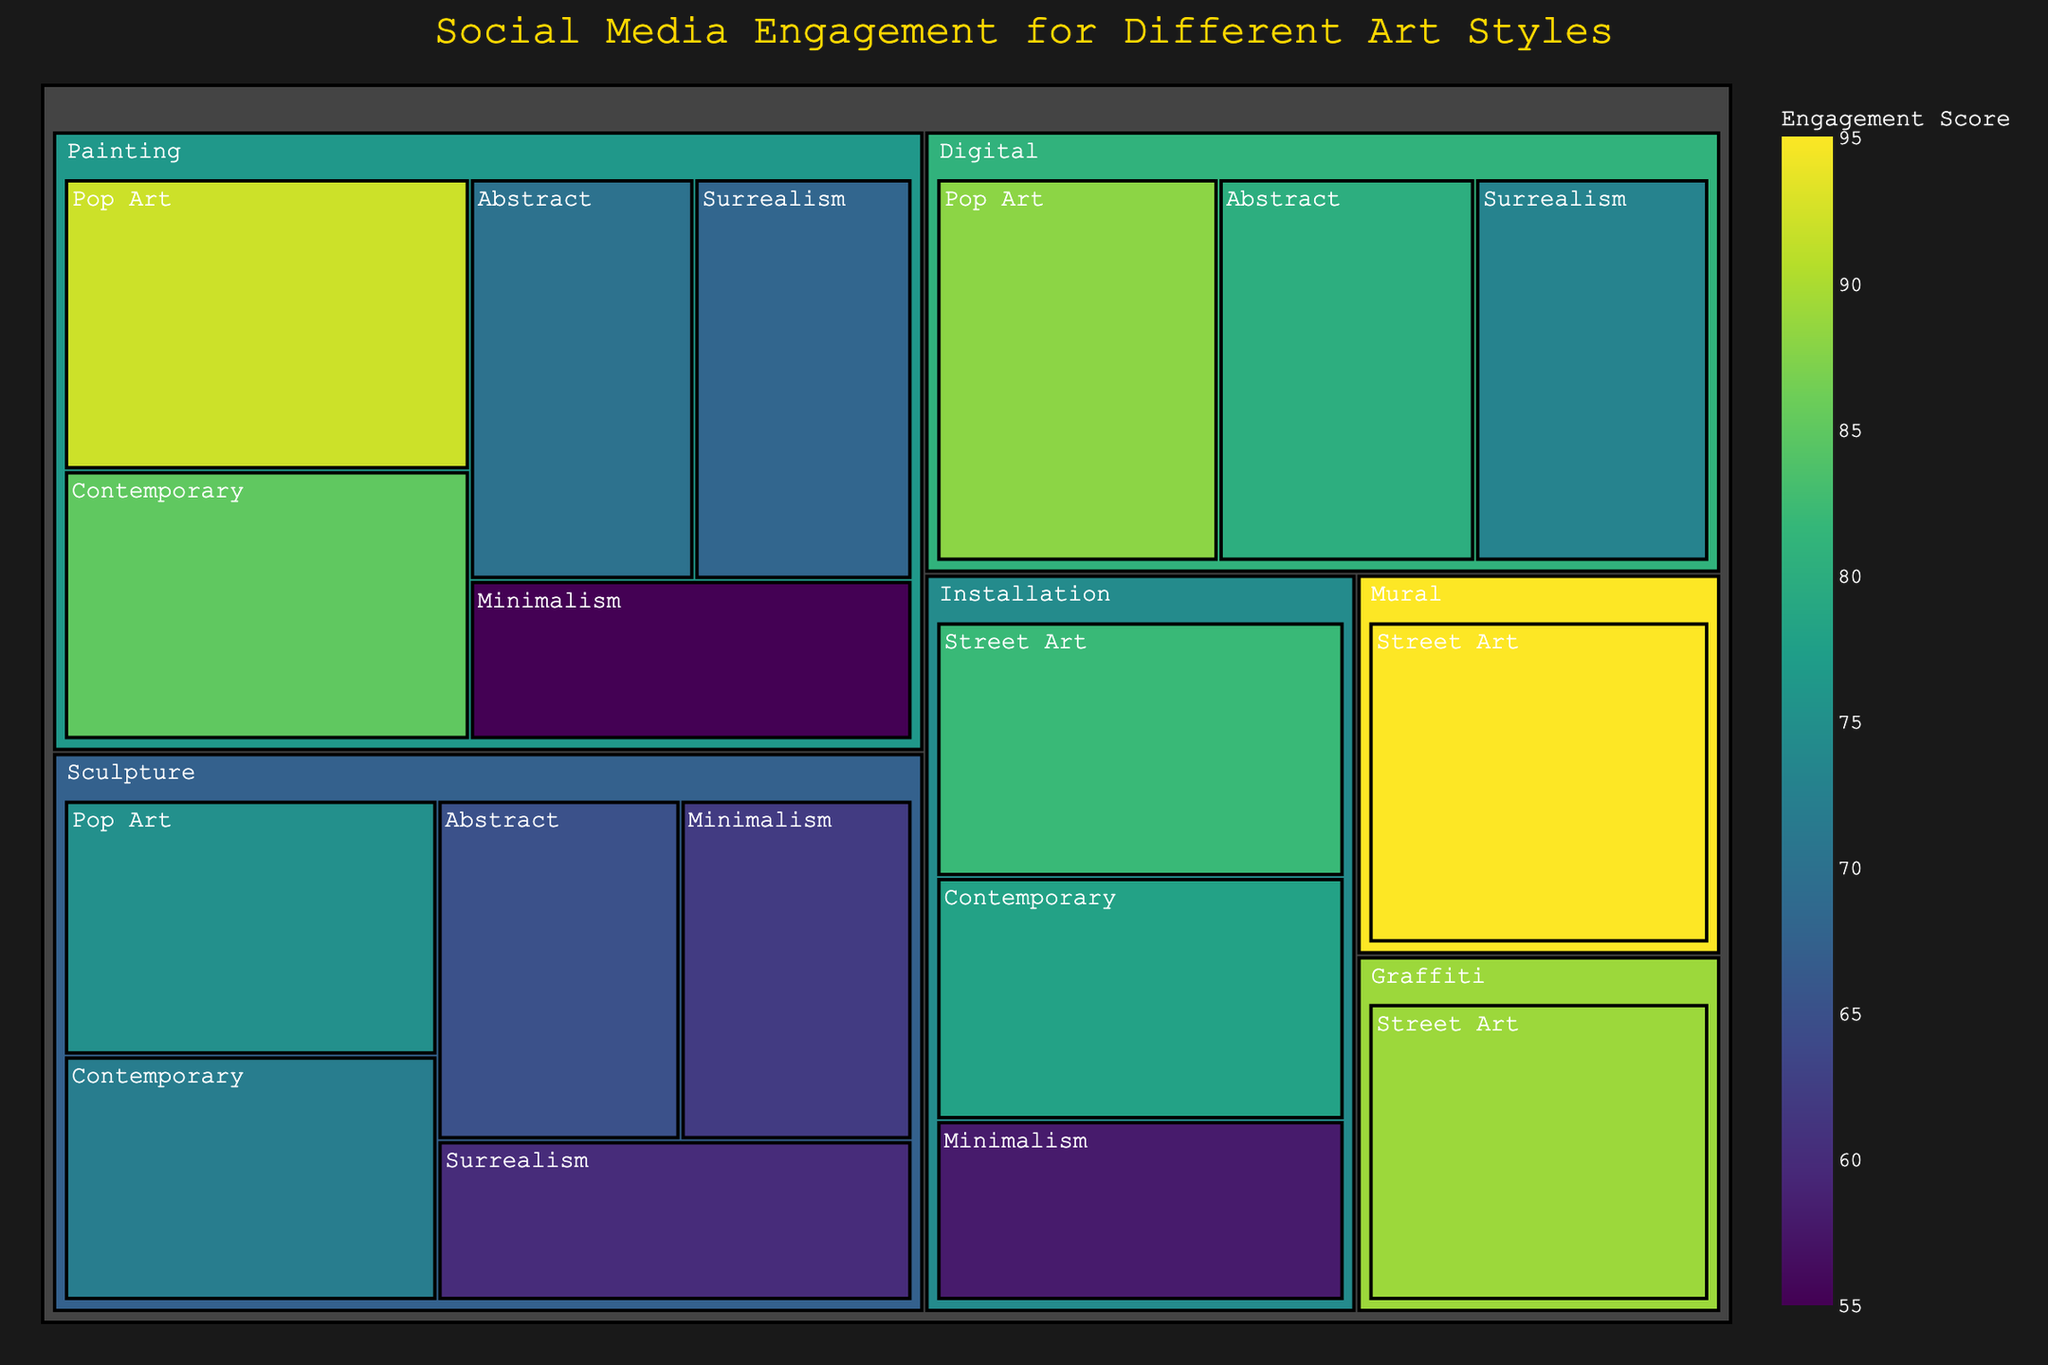What's the title of the treemap? The title of the treemap is displayed at the top center of the figure in a gold color font.
Answer: Social Media Engagement for Different Art Styles Which art style and category combination has the highest engagement score? By looking at the treemap, the largest and darkest green segment represents the highest engagement score.
Answer: Street Art - Mural What's the engagement score for Pop Art in the painting category? Locate the segment labeled 'Pop Art' under 'Painting' in the treemap. The hover data or direct label shows the engagement score.
Answer: 92 How many different categories are shown in the treemap? The treemap is divided into top-level categories shown as the first level of the hierarchy. Count these divisions.
Answer: 6 What is the total engagement score for all Contemporary art styles? Identify and sum all the engagement scores under Contemporary (Painting, Sculpture, Installation). 85 + 72 + 78.
Answer: 235 Which category across all art styles has the lowest engagement score? Locate the smallest and lightest-colored segment within the entire treemap, which indicates the lowest score.
Answer: Minimalism - Painting Compare the engagement scores of Street Art-Graffiti and Pop Art-Digital. Which has a higher score? Find 'Street Art - Graffiti' and 'Pop Art - Digital' in the treemap and compare their engagement scores.
Answer: Pop Art - Digital What is the combined engagement score of all Digital artworks across all art styles? Identify and sum all the engagement scores under Digital category. 80 (Abstract) + 88 (Pop Art) + 73 (Surrealism).
Answer: 241 Which art style has the most varied engagement scores across its categories? Evaluate the range of engagement scores within each art style by looking at the spread from highest to lowest scores within each style.
Answer: Contemporary Which two art styles have the closest engagement scores in the painting category? Compare the engagement scores under Painting for all art styles and see which scores are most similar.
Answer: Surrealism and Abstract 